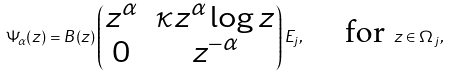<formula> <loc_0><loc_0><loc_500><loc_500>\Psi _ { \alpha } ( z ) = B ( z ) \begin{pmatrix} z ^ { \alpha } & \kappa z ^ { \alpha } \log z \\ 0 & z ^ { - \alpha } \end{pmatrix} E _ { j } , \quad \text { for } z \in \Omega _ { j } ,</formula> 